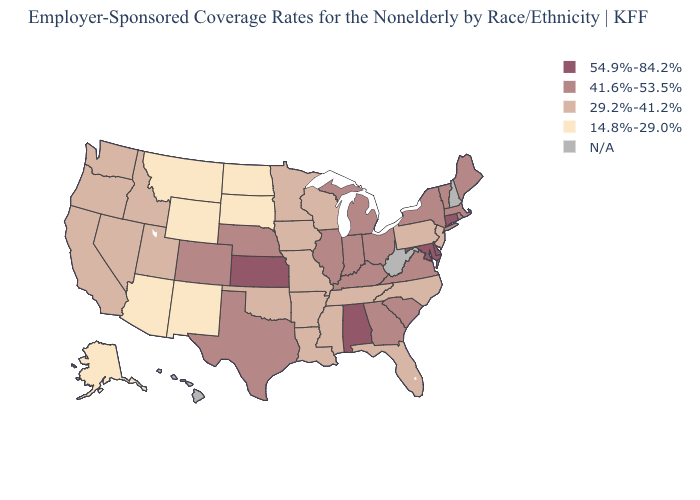Does the first symbol in the legend represent the smallest category?
Keep it brief. No. What is the value of Georgia?
Be succinct. 41.6%-53.5%. What is the highest value in the West ?
Quick response, please. 41.6%-53.5%. Name the states that have a value in the range 29.2%-41.2%?
Give a very brief answer. Arkansas, California, Florida, Idaho, Iowa, Louisiana, Minnesota, Mississippi, Missouri, Nevada, New Jersey, North Carolina, Oklahoma, Oregon, Pennsylvania, Tennessee, Utah, Washington, Wisconsin. What is the value of Ohio?
Keep it brief. 41.6%-53.5%. Among the states that border Illinois , which have the lowest value?
Write a very short answer. Iowa, Missouri, Wisconsin. Which states hav the highest value in the West?
Answer briefly. Colorado. What is the value of Kansas?
Concise answer only. 54.9%-84.2%. Name the states that have a value in the range 14.8%-29.0%?
Answer briefly. Alaska, Arizona, Montana, New Mexico, North Dakota, South Dakota, Wyoming. What is the value of Nebraska?
Keep it brief. 41.6%-53.5%. Among the states that border Wisconsin , does Michigan have the lowest value?
Keep it brief. No. Does the map have missing data?
Quick response, please. Yes. Name the states that have a value in the range 29.2%-41.2%?
Keep it brief. Arkansas, California, Florida, Idaho, Iowa, Louisiana, Minnesota, Mississippi, Missouri, Nevada, New Jersey, North Carolina, Oklahoma, Oregon, Pennsylvania, Tennessee, Utah, Washington, Wisconsin. What is the value of Indiana?
Write a very short answer. 41.6%-53.5%. 